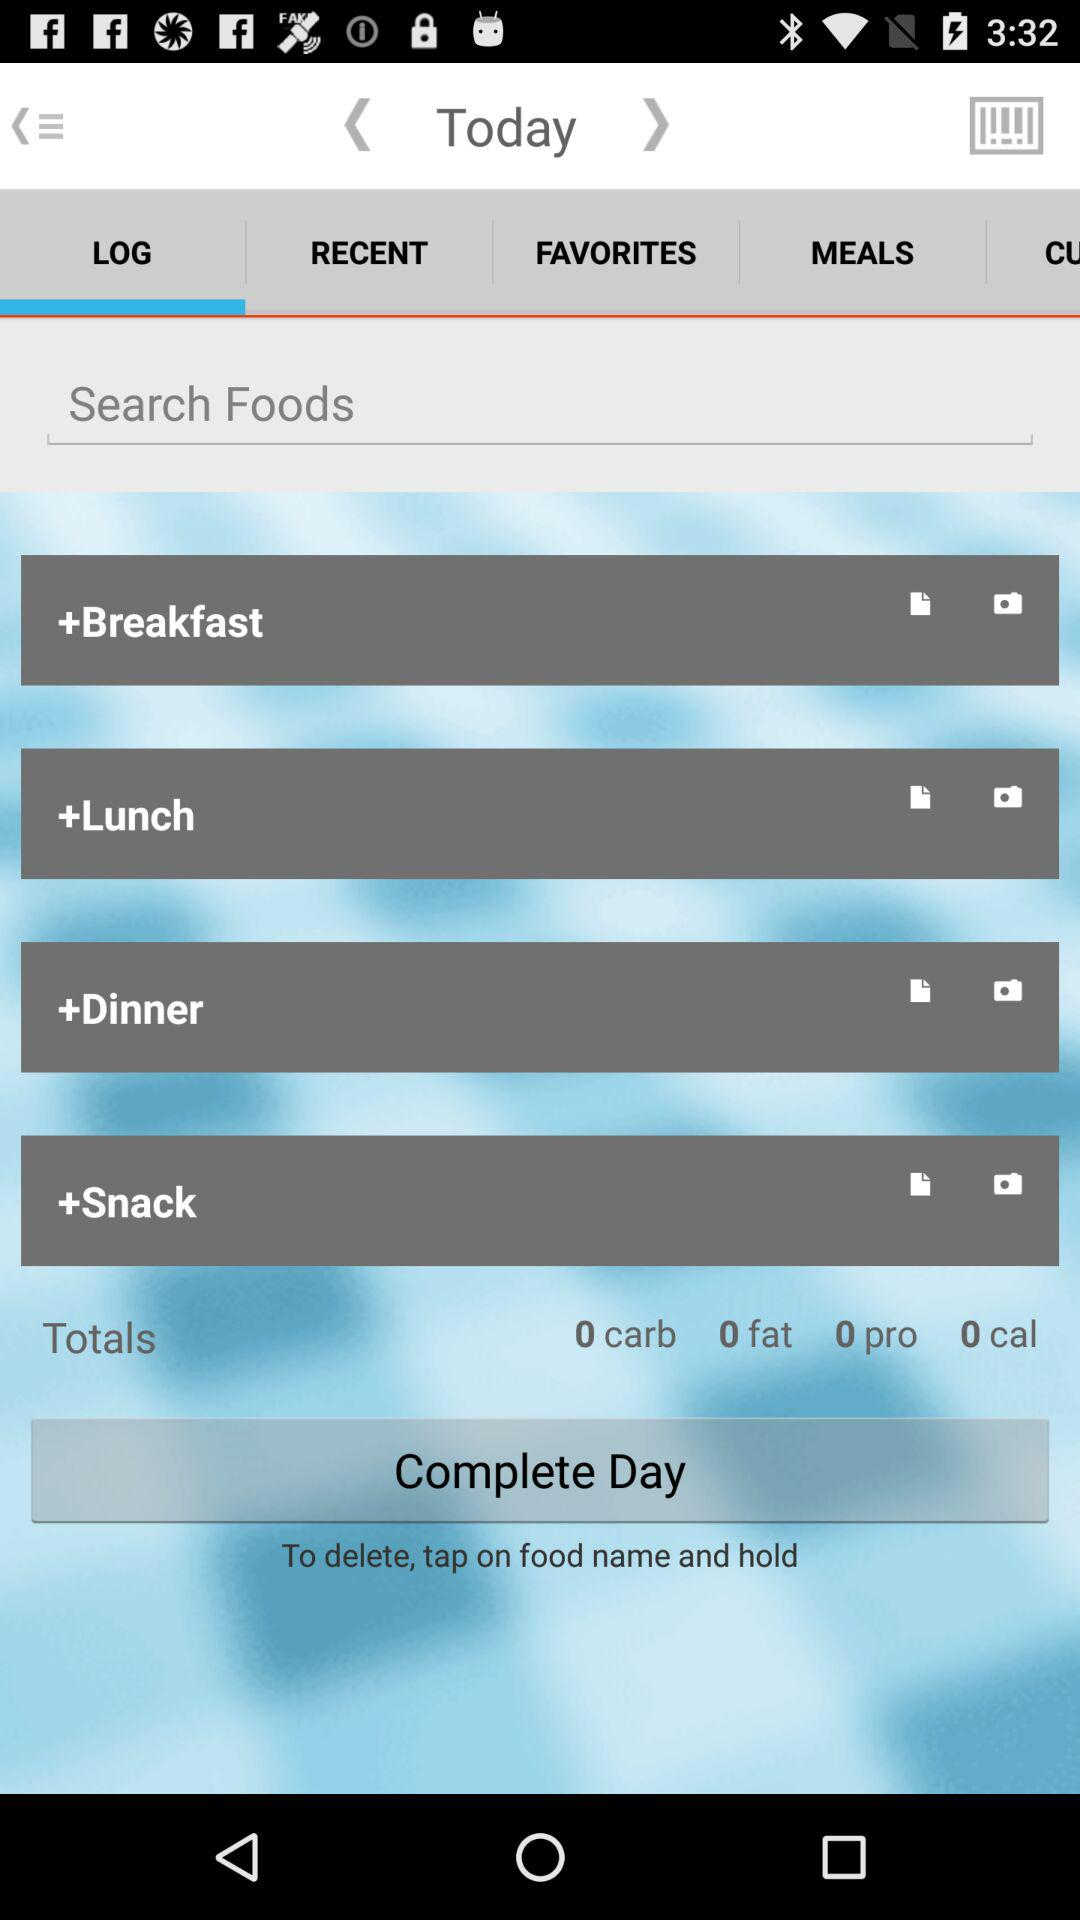What is the calorie count? The calorie count is 0. 